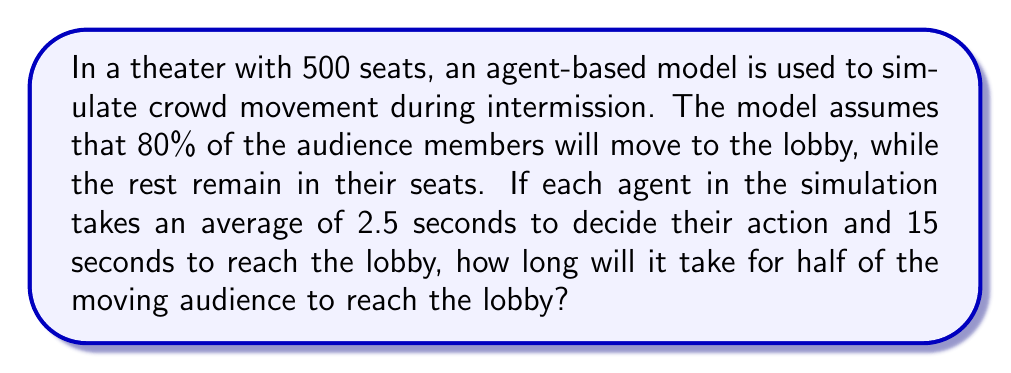Can you answer this question? Let's break this problem down step-by-step:

1. Calculate the number of audience members moving to the lobby:
   $$ 500 \times 0.80 = 400 \text{ people} $$

2. Calculate the time it takes for one person to reach the lobby:
   $$ 2.5 \text{ seconds (decision time)} + 15 \text{ seconds (movement time)} = 17.5 \text{ seconds} $$

3. We need to find how long it takes for half of the moving audience to reach the lobby:
   $$ \text{Half of moving audience} = 400 \div 2 = 200 \text{ people} $$

4. In an agent-based model, agents act independently but simultaneously. This means that all 400 people start moving at the same time, and it will take exactly 17.5 seconds for the first group to reach the lobby.

5. Since we're asked about half of the moving audience (200 people), and all agents move simultaneously, it will still take 17.5 seconds for this group to reach the lobby.

This problem illustrates how agent-based modeling can simulate complex crowd behaviors in a theater setting, which would be relevant to a theater enthusiast. The concept of simultaneous movement in the model mirrors the way real audiences might behave during an intermission, providing an interesting parallel between computational mathematics and the theater experience.
Answer: 17.5 seconds 